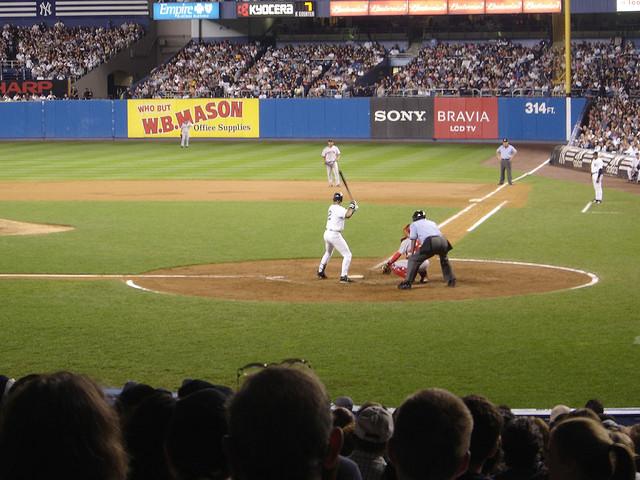What are the players standing on?
Quick response, please. Field. What business is on the sign that is  white and black?
Concise answer only. Sony. Which advertiser sells office supplies?
Give a very brief answer. Wb mason. 